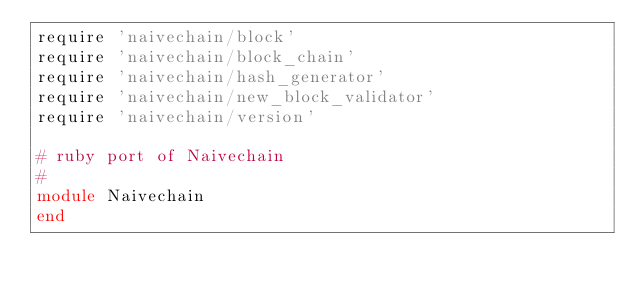Convert code to text. <code><loc_0><loc_0><loc_500><loc_500><_Ruby_>require 'naivechain/block'
require 'naivechain/block_chain'
require 'naivechain/hash_generator'
require 'naivechain/new_block_validator'
require 'naivechain/version'

# ruby port of Naivechain
#
module Naivechain
end
</code> 